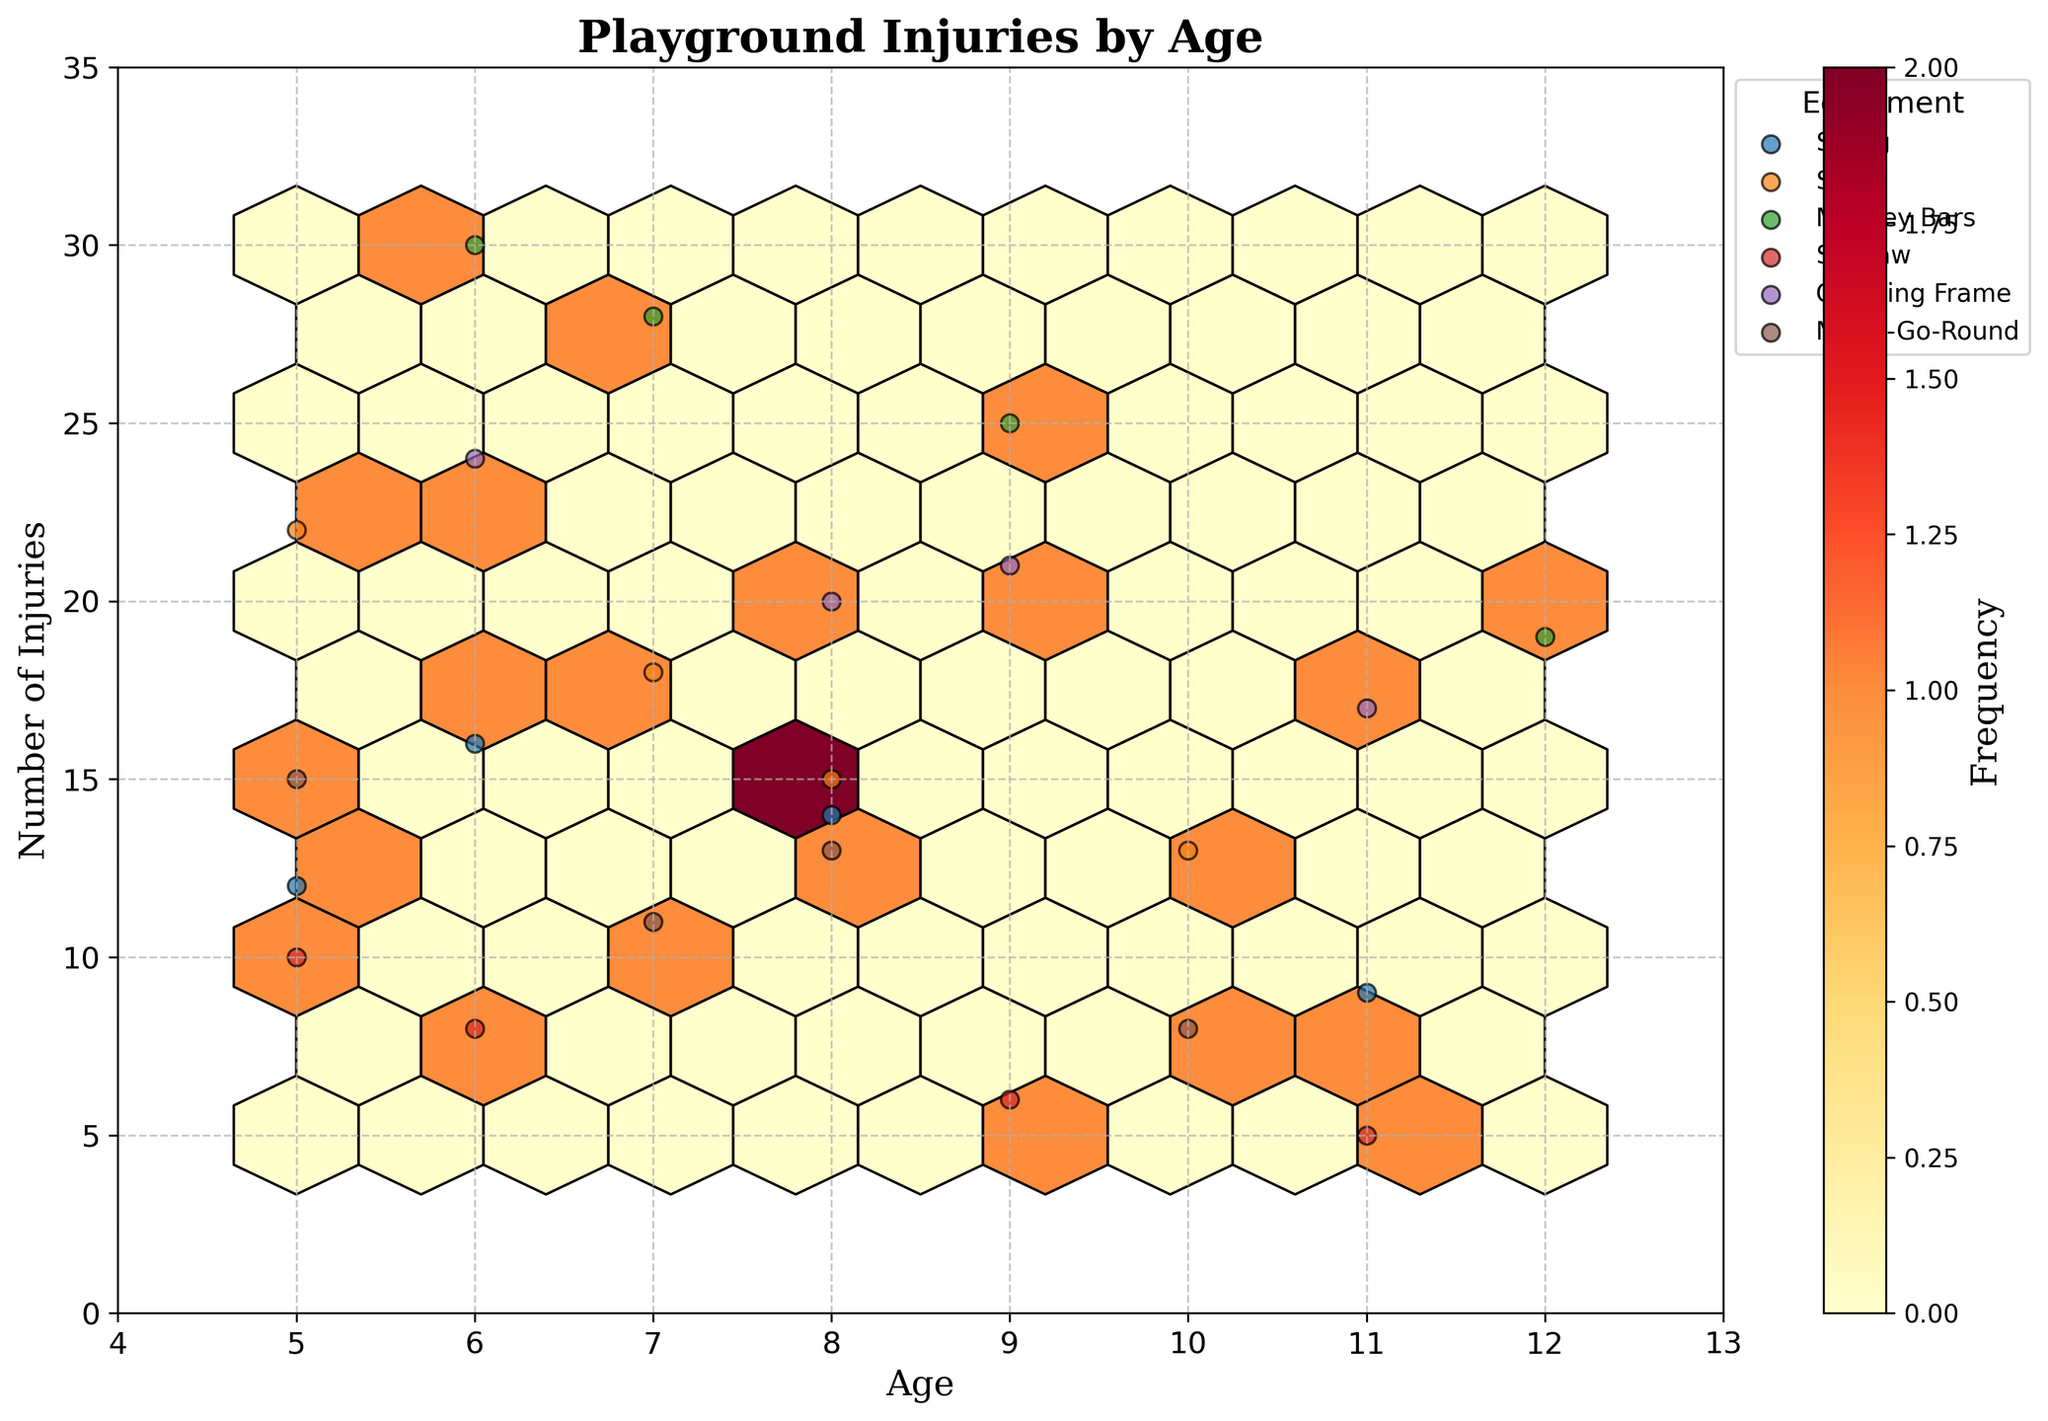What does the title of the plot indicate? The title of the plot is "Playground Injuries by Age," which indicates that the plot shows the distribution of playground injuries across different ages of children.
Answer: Playground Injuries by Age What are the ranges of the X and Y axes? The X axis ranges from 4 to 13, representing the ages of children, while the Y axis ranges from 0 to the maximum plus 5 (likely 30), representing the number of injuries.
Answer: X: 4-13, Y: 0-30 Which equipment type has the highest frequency of injuries at any age observed in the plot? By examining the hexbin color intensities and scatter points, we can see that "Monkey Bars" have the highest individual injury counts, specifically around the age of 6 and 7, indicated by darker hexes.
Answer: Monkey Bars What's the average number of injuries for children aged 5? The plot shows data points: Swings (12), Merry-Go-Round (15), Slide (22), Seesaw (10). Summing these: 12 + 15 + 22 + 10 = 59. The average is 59/4 = 14.75.
Answer: 14.75 Between which ages do the highest frequencies of injuries occur? The highest frequencies of injuries occur in the 6-8 age range, as indicated by the darkest hexagons in the plot.
Answer: 6-8 Comparing the equipment "Swing" and "Slide," which has more injuries across all ages? By looking at the scattered points, Slides have more injury incidents especially at around age 5 and 7, compared to Swings.
Answer: Slide What does the colorbar in the plot represent? The colorbar represents the frequency of injuries with lighter colors showing fewer injuries and darker colors showing higher frequencies.
Answer: Frequency On what age is the clustering of injuries around "Climbing Frame" most prominent? Injuries related to "Climbing Frame" are clustered around ages 8 and 9, as seen from the scatter points and hex density.
Answer: 8 and 9 How many equipment types are represented in the plot? The legend shows that there are 6 equipment types: Swing, Slide, Monkey Bars, Seesaw, Climbing Frame, and Merry-Go-Round.
Answer: 6 What age range has the least number of observed injuries and for which equipment? Age 11 has the least number of observed injuries, particularly for Seesaw and Swing, as they have the lowest counts shown by the data points.
Answer: Age 11, Seesaw and Swing 